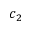Convert formula to latex. <formula><loc_0><loc_0><loc_500><loc_500>c _ { 2 }</formula> 